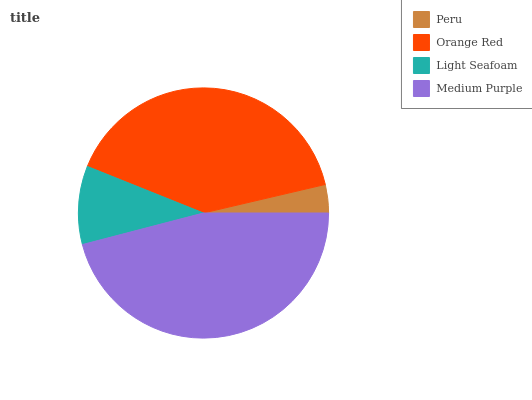Is Peru the minimum?
Answer yes or no. Yes. Is Medium Purple the maximum?
Answer yes or no. Yes. Is Orange Red the minimum?
Answer yes or no. No. Is Orange Red the maximum?
Answer yes or no. No. Is Orange Red greater than Peru?
Answer yes or no. Yes. Is Peru less than Orange Red?
Answer yes or no. Yes. Is Peru greater than Orange Red?
Answer yes or no. No. Is Orange Red less than Peru?
Answer yes or no. No. Is Orange Red the high median?
Answer yes or no. Yes. Is Light Seafoam the low median?
Answer yes or no. Yes. Is Medium Purple the high median?
Answer yes or no. No. Is Peru the low median?
Answer yes or no. No. 